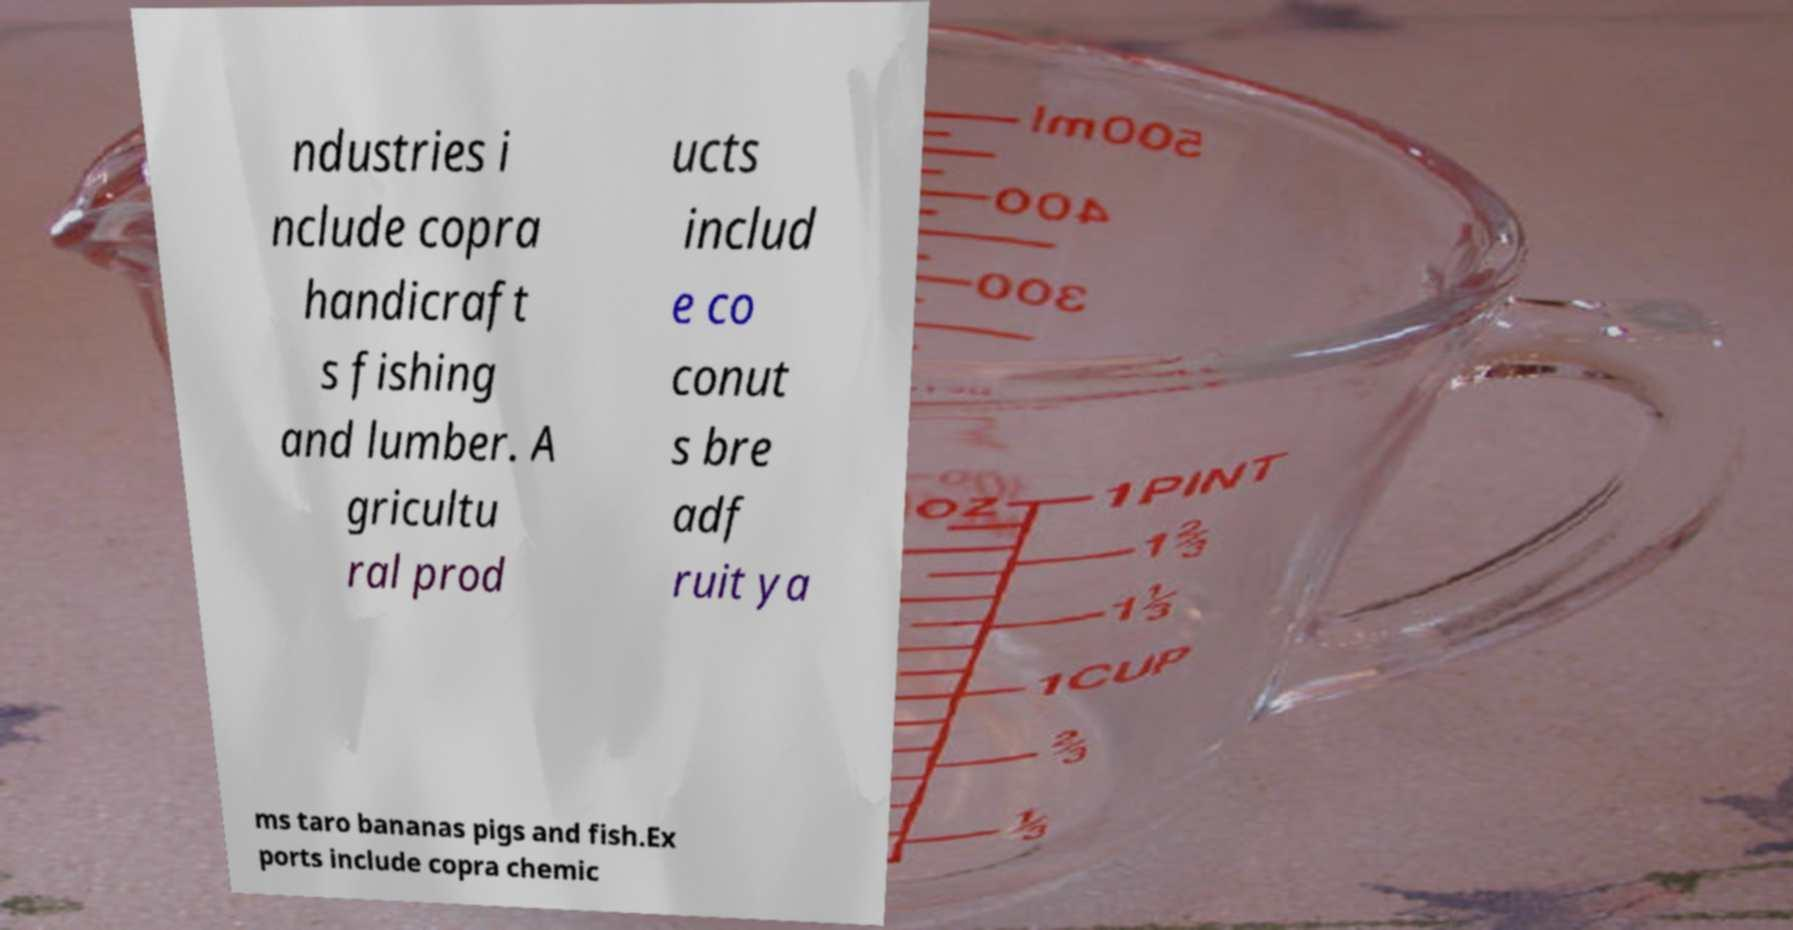Can you read and provide the text displayed in the image?This photo seems to have some interesting text. Can you extract and type it out for me? ndustries i nclude copra handicraft s fishing and lumber. A gricultu ral prod ucts includ e co conut s bre adf ruit ya ms taro bananas pigs and fish.Ex ports include copra chemic 